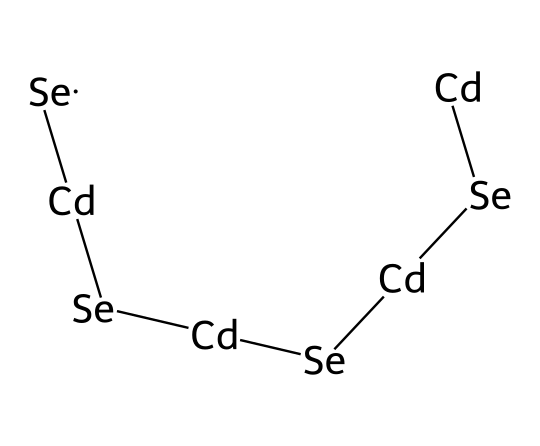What atoms are present in the chemical structure? The structure includes cadmium (Cd) and selenium (Se) atoms, which can be identified by their symbols.
Answer: cadmium, selenium How many cadmium atoms are in the structure? Counting the occurrences of "Cd" in the SMILES representation reveals that there are four cadmium atoms.
Answer: four How many selenium atoms are present in the chemical? By counting the occurrences of "Se" in the SMILES representation, we find that there are three selenium atoms.
Answer: three What type of chemical bonding is predominantly featured in this quantum dot structure? The SMILES representation shows a sequence of Cd and Se atoms, indicating that they are linked, suggesting covalent bonding is present.
Answer: covalent What type of nanomaterial is represented by this structure? The chemical structure corresponds to quantum dots, which are semiconductor materials known for their unique optical properties, applicable in QLED TVs.
Answer: quantum dots What is the significance of cadmium selenide in electronics? Cadmium selenide is crucial in electronics due to its semiconductor properties, which allow for efficient light emission in display technologies like QLED TVs.
Answer: semiconductor properties 